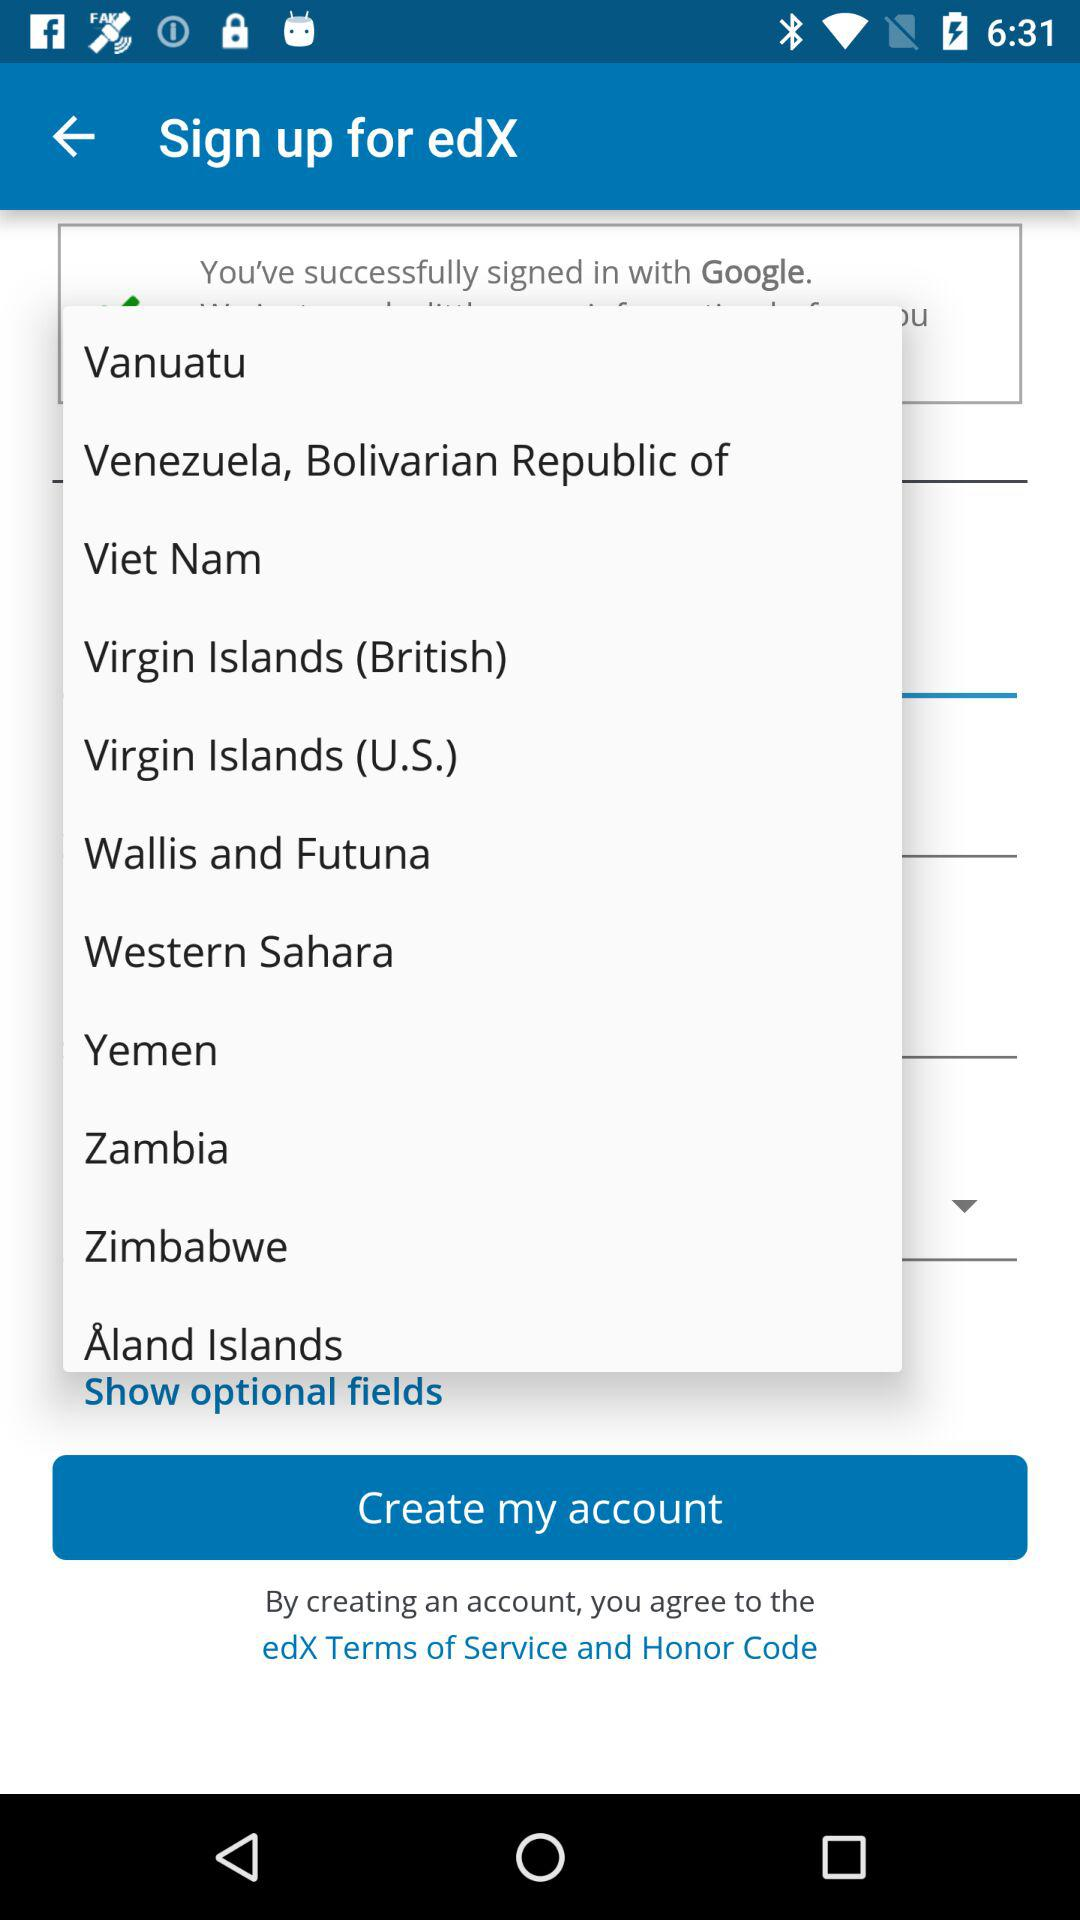What is the name of the application? The name of the application is "edX". 